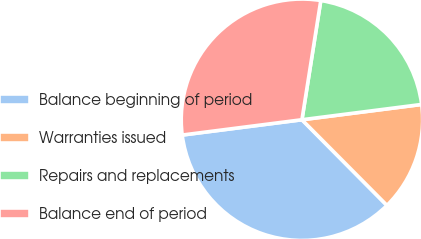Convert chart to OTSL. <chart><loc_0><loc_0><loc_500><loc_500><pie_chart><fcel>Balance beginning of period<fcel>Warranties issued<fcel>Repairs and replacements<fcel>Balance end of period<nl><fcel>35.42%<fcel>14.58%<fcel>20.48%<fcel>29.52%<nl></chart> 